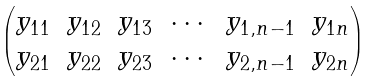<formula> <loc_0><loc_0><loc_500><loc_500>\begin{pmatrix} y _ { 1 1 } & y _ { 1 2 } & y _ { 1 3 } & \cdots & y _ { 1 , n - 1 } & y _ { 1 n } \\ y _ { 2 1 } & y _ { 2 2 } & y _ { 2 3 } & \cdots & y _ { 2 , n - 1 } & y _ { 2 n } \end{pmatrix}</formula> 